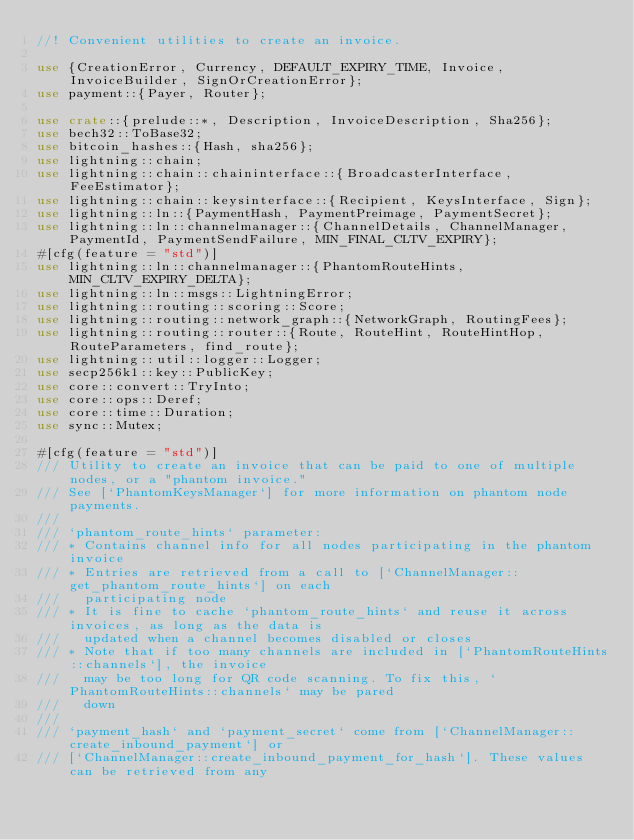Convert code to text. <code><loc_0><loc_0><loc_500><loc_500><_Rust_>//! Convenient utilities to create an invoice.

use {CreationError, Currency, DEFAULT_EXPIRY_TIME, Invoice, InvoiceBuilder, SignOrCreationError};
use payment::{Payer, Router};

use crate::{prelude::*, Description, InvoiceDescription, Sha256};
use bech32::ToBase32;
use bitcoin_hashes::{Hash, sha256};
use lightning::chain;
use lightning::chain::chaininterface::{BroadcasterInterface, FeeEstimator};
use lightning::chain::keysinterface::{Recipient, KeysInterface, Sign};
use lightning::ln::{PaymentHash, PaymentPreimage, PaymentSecret};
use lightning::ln::channelmanager::{ChannelDetails, ChannelManager, PaymentId, PaymentSendFailure, MIN_FINAL_CLTV_EXPIRY};
#[cfg(feature = "std")]
use lightning::ln::channelmanager::{PhantomRouteHints, MIN_CLTV_EXPIRY_DELTA};
use lightning::ln::msgs::LightningError;
use lightning::routing::scoring::Score;
use lightning::routing::network_graph::{NetworkGraph, RoutingFees};
use lightning::routing::router::{Route, RouteHint, RouteHintHop, RouteParameters, find_route};
use lightning::util::logger::Logger;
use secp256k1::key::PublicKey;
use core::convert::TryInto;
use core::ops::Deref;
use core::time::Duration;
use sync::Mutex;

#[cfg(feature = "std")]
/// Utility to create an invoice that can be paid to one of multiple nodes, or a "phantom invoice."
/// See [`PhantomKeysManager`] for more information on phantom node payments.
///
/// `phantom_route_hints` parameter:
/// * Contains channel info for all nodes participating in the phantom invoice
/// * Entries are retrieved from a call to [`ChannelManager::get_phantom_route_hints`] on each
///   participating node
/// * It is fine to cache `phantom_route_hints` and reuse it across invoices, as long as the data is
///   updated when a channel becomes disabled or closes
/// * Note that if too many channels are included in [`PhantomRouteHints::channels`], the invoice
///   may be too long for QR code scanning. To fix this, `PhantomRouteHints::channels` may be pared
///   down
///
/// `payment_hash` and `payment_secret` come from [`ChannelManager::create_inbound_payment`] or
/// [`ChannelManager::create_inbound_payment_for_hash`]. These values can be retrieved from any</code> 